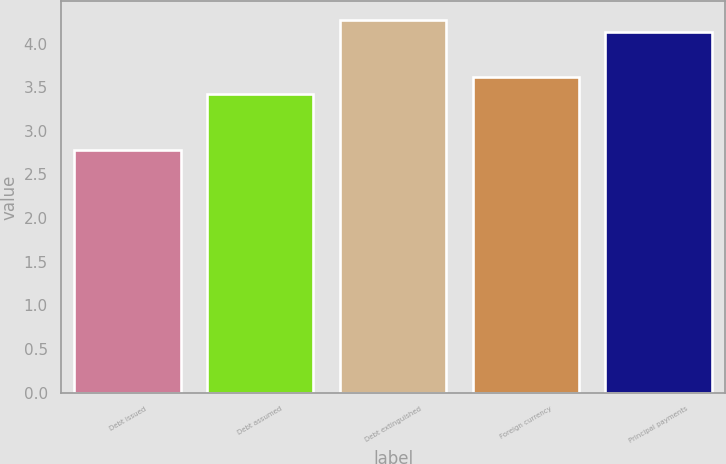Convert chart to OTSL. <chart><loc_0><loc_0><loc_500><loc_500><bar_chart><fcel>Debt issued<fcel>Debt assumed<fcel>Debt extinguished<fcel>Foreign currency<fcel>Principal payments<nl><fcel>2.78<fcel>3.42<fcel>4.27<fcel>3.62<fcel>4.13<nl></chart> 